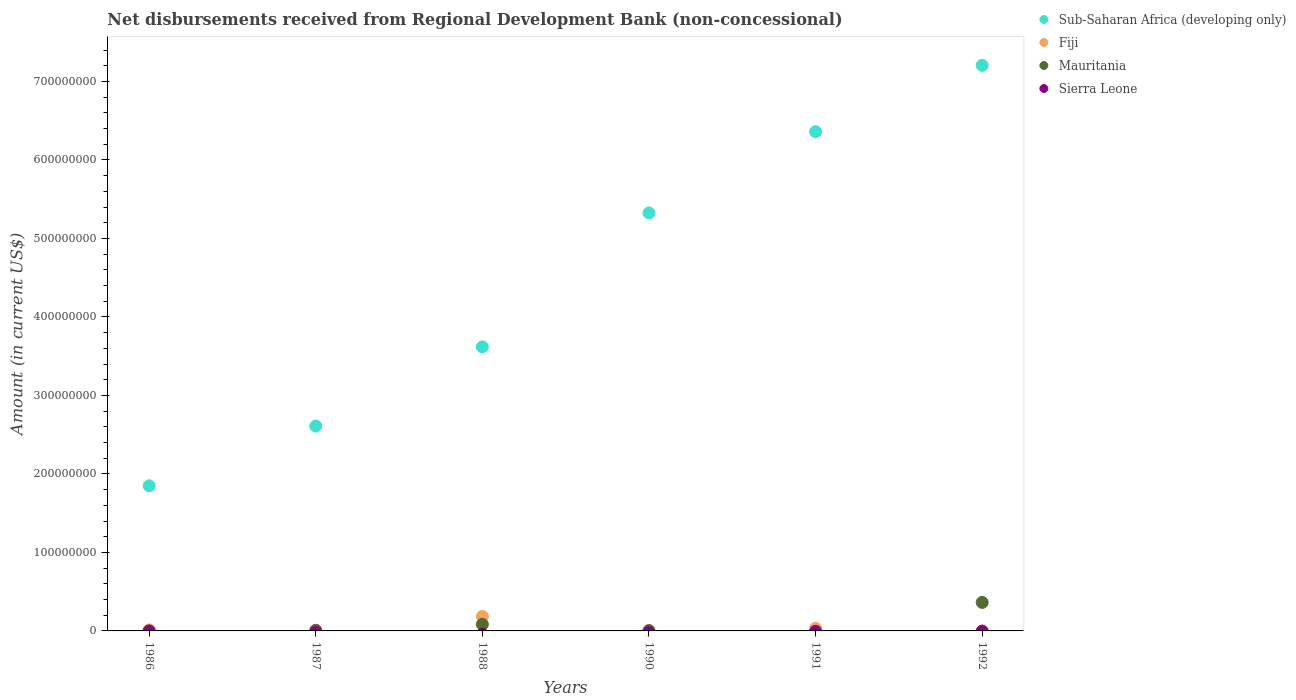Is the number of dotlines equal to the number of legend labels?
Ensure brevity in your answer.  No. What is the amount of disbursements received from Regional Development Bank in Mauritania in 1988?
Offer a very short reply. 8.38e+06. Across all years, what is the maximum amount of disbursements received from Regional Development Bank in Sub-Saharan Africa (developing only)?
Offer a very short reply. 7.20e+08. What is the total amount of disbursements received from Regional Development Bank in Sub-Saharan Africa (developing only) in the graph?
Offer a very short reply. 2.70e+09. What is the difference between the amount of disbursements received from Regional Development Bank in Mauritania in 1986 and that in 1990?
Provide a short and direct response. -5.11e+05. What is the difference between the amount of disbursements received from Regional Development Bank in Mauritania in 1992 and the amount of disbursements received from Regional Development Bank in Fiji in 1986?
Keep it short and to the point. 3.50e+07. What is the average amount of disbursements received from Regional Development Bank in Sierra Leone per year?
Make the answer very short. 0. In the year 1992, what is the difference between the amount of disbursements received from Regional Development Bank in Mauritania and amount of disbursements received from Regional Development Bank in Sub-Saharan Africa (developing only)?
Give a very brief answer. -6.84e+08. What is the ratio of the amount of disbursements received from Regional Development Bank in Fiji in 1987 to that in 1988?
Make the answer very short. 0.04. Is the amount of disbursements received from Regional Development Bank in Sub-Saharan Africa (developing only) in 1988 less than that in 1990?
Provide a short and direct response. Yes. Is the difference between the amount of disbursements received from Regional Development Bank in Mauritania in 1987 and 1990 greater than the difference between the amount of disbursements received from Regional Development Bank in Sub-Saharan Africa (developing only) in 1987 and 1990?
Offer a terse response. Yes. What is the difference between the highest and the second highest amount of disbursements received from Regional Development Bank in Fiji?
Offer a very short reply. 1.51e+07. What is the difference between the highest and the lowest amount of disbursements received from Regional Development Bank in Fiji?
Provide a short and direct response. 1.85e+07. In how many years, is the amount of disbursements received from Regional Development Bank in Fiji greater than the average amount of disbursements received from Regional Development Bank in Fiji taken over all years?
Your answer should be very brief. 1. Is the sum of the amount of disbursements received from Regional Development Bank in Mauritania in 1990 and 1992 greater than the maximum amount of disbursements received from Regional Development Bank in Fiji across all years?
Keep it short and to the point. Yes. Is the amount of disbursements received from Regional Development Bank in Sub-Saharan Africa (developing only) strictly greater than the amount of disbursements received from Regional Development Bank in Sierra Leone over the years?
Your answer should be compact. Yes. Is the amount of disbursements received from Regional Development Bank in Sierra Leone strictly less than the amount of disbursements received from Regional Development Bank in Fiji over the years?
Your answer should be compact. No. How many dotlines are there?
Your answer should be very brief. 3. How many years are there in the graph?
Offer a very short reply. 6. Does the graph contain any zero values?
Provide a short and direct response. Yes. How many legend labels are there?
Keep it short and to the point. 4. How are the legend labels stacked?
Your answer should be very brief. Vertical. What is the title of the graph?
Ensure brevity in your answer.  Net disbursements received from Regional Development Bank (non-concessional). Does "Kenya" appear as one of the legend labels in the graph?
Offer a very short reply. No. What is the label or title of the X-axis?
Provide a succinct answer. Years. What is the Amount (in current US$) of Sub-Saharan Africa (developing only) in 1986?
Keep it short and to the point. 1.85e+08. What is the Amount (in current US$) in Fiji in 1986?
Keep it short and to the point. 1.34e+06. What is the Amount (in current US$) of Mauritania in 1986?
Ensure brevity in your answer.  1.90e+04. What is the Amount (in current US$) of Sierra Leone in 1986?
Offer a very short reply. 0. What is the Amount (in current US$) of Sub-Saharan Africa (developing only) in 1987?
Your answer should be compact. 2.61e+08. What is the Amount (in current US$) in Fiji in 1987?
Your answer should be compact. 8.21e+05. What is the Amount (in current US$) of Mauritania in 1987?
Offer a terse response. 7.30e+05. What is the Amount (in current US$) in Sub-Saharan Africa (developing only) in 1988?
Make the answer very short. 3.62e+08. What is the Amount (in current US$) of Fiji in 1988?
Your response must be concise. 1.85e+07. What is the Amount (in current US$) of Mauritania in 1988?
Provide a short and direct response. 8.38e+06. What is the Amount (in current US$) in Sub-Saharan Africa (developing only) in 1990?
Your response must be concise. 5.33e+08. What is the Amount (in current US$) in Fiji in 1990?
Provide a succinct answer. 0. What is the Amount (in current US$) in Mauritania in 1990?
Provide a succinct answer. 5.30e+05. What is the Amount (in current US$) of Sub-Saharan Africa (developing only) in 1991?
Your answer should be very brief. 6.36e+08. What is the Amount (in current US$) of Fiji in 1991?
Make the answer very short. 3.35e+06. What is the Amount (in current US$) in Mauritania in 1991?
Make the answer very short. 0. What is the Amount (in current US$) in Sierra Leone in 1991?
Offer a very short reply. 0. What is the Amount (in current US$) of Sub-Saharan Africa (developing only) in 1992?
Your response must be concise. 7.20e+08. What is the Amount (in current US$) in Mauritania in 1992?
Provide a succinct answer. 3.63e+07. Across all years, what is the maximum Amount (in current US$) of Sub-Saharan Africa (developing only)?
Your answer should be compact. 7.20e+08. Across all years, what is the maximum Amount (in current US$) in Fiji?
Your answer should be compact. 1.85e+07. Across all years, what is the maximum Amount (in current US$) in Mauritania?
Your answer should be compact. 3.63e+07. Across all years, what is the minimum Amount (in current US$) in Sub-Saharan Africa (developing only)?
Your answer should be compact. 1.85e+08. Across all years, what is the minimum Amount (in current US$) in Fiji?
Give a very brief answer. 0. What is the total Amount (in current US$) in Sub-Saharan Africa (developing only) in the graph?
Ensure brevity in your answer.  2.70e+09. What is the total Amount (in current US$) of Fiji in the graph?
Ensure brevity in your answer.  2.40e+07. What is the total Amount (in current US$) in Mauritania in the graph?
Offer a terse response. 4.60e+07. What is the difference between the Amount (in current US$) of Sub-Saharan Africa (developing only) in 1986 and that in 1987?
Keep it short and to the point. -7.60e+07. What is the difference between the Amount (in current US$) in Fiji in 1986 and that in 1987?
Offer a terse response. 5.17e+05. What is the difference between the Amount (in current US$) of Mauritania in 1986 and that in 1987?
Offer a very short reply. -7.11e+05. What is the difference between the Amount (in current US$) of Sub-Saharan Africa (developing only) in 1986 and that in 1988?
Your answer should be very brief. -1.77e+08. What is the difference between the Amount (in current US$) of Fiji in 1986 and that in 1988?
Keep it short and to the point. -1.71e+07. What is the difference between the Amount (in current US$) of Mauritania in 1986 and that in 1988?
Your answer should be very brief. -8.36e+06. What is the difference between the Amount (in current US$) of Sub-Saharan Africa (developing only) in 1986 and that in 1990?
Make the answer very short. -3.48e+08. What is the difference between the Amount (in current US$) of Mauritania in 1986 and that in 1990?
Offer a very short reply. -5.11e+05. What is the difference between the Amount (in current US$) in Sub-Saharan Africa (developing only) in 1986 and that in 1991?
Ensure brevity in your answer.  -4.51e+08. What is the difference between the Amount (in current US$) of Fiji in 1986 and that in 1991?
Provide a succinct answer. -2.01e+06. What is the difference between the Amount (in current US$) of Sub-Saharan Africa (developing only) in 1986 and that in 1992?
Ensure brevity in your answer.  -5.36e+08. What is the difference between the Amount (in current US$) of Mauritania in 1986 and that in 1992?
Your answer should be very brief. -3.63e+07. What is the difference between the Amount (in current US$) of Sub-Saharan Africa (developing only) in 1987 and that in 1988?
Offer a very short reply. -1.01e+08. What is the difference between the Amount (in current US$) in Fiji in 1987 and that in 1988?
Offer a terse response. -1.76e+07. What is the difference between the Amount (in current US$) of Mauritania in 1987 and that in 1988?
Offer a very short reply. -7.65e+06. What is the difference between the Amount (in current US$) of Sub-Saharan Africa (developing only) in 1987 and that in 1990?
Provide a short and direct response. -2.72e+08. What is the difference between the Amount (in current US$) of Sub-Saharan Africa (developing only) in 1987 and that in 1991?
Keep it short and to the point. -3.75e+08. What is the difference between the Amount (in current US$) in Fiji in 1987 and that in 1991?
Make the answer very short. -2.53e+06. What is the difference between the Amount (in current US$) in Sub-Saharan Africa (developing only) in 1987 and that in 1992?
Keep it short and to the point. -4.60e+08. What is the difference between the Amount (in current US$) of Mauritania in 1987 and that in 1992?
Your answer should be very brief. -3.56e+07. What is the difference between the Amount (in current US$) of Sub-Saharan Africa (developing only) in 1988 and that in 1990?
Offer a terse response. -1.71e+08. What is the difference between the Amount (in current US$) in Mauritania in 1988 and that in 1990?
Offer a terse response. 7.85e+06. What is the difference between the Amount (in current US$) of Sub-Saharan Africa (developing only) in 1988 and that in 1991?
Ensure brevity in your answer.  -2.74e+08. What is the difference between the Amount (in current US$) of Fiji in 1988 and that in 1991?
Make the answer very short. 1.51e+07. What is the difference between the Amount (in current US$) of Sub-Saharan Africa (developing only) in 1988 and that in 1992?
Give a very brief answer. -3.59e+08. What is the difference between the Amount (in current US$) of Mauritania in 1988 and that in 1992?
Make the answer very short. -2.79e+07. What is the difference between the Amount (in current US$) in Sub-Saharan Africa (developing only) in 1990 and that in 1991?
Offer a very short reply. -1.03e+08. What is the difference between the Amount (in current US$) of Sub-Saharan Africa (developing only) in 1990 and that in 1992?
Offer a very short reply. -1.88e+08. What is the difference between the Amount (in current US$) of Mauritania in 1990 and that in 1992?
Your answer should be compact. -3.58e+07. What is the difference between the Amount (in current US$) of Sub-Saharan Africa (developing only) in 1991 and that in 1992?
Provide a succinct answer. -8.45e+07. What is the difference between the Amount (in current US$) of Sub-Saharan Africa (developing only) in 1986 and the Amount (in current US$) of Fiji in 1987?
Your answer should be compact. 1.84e+08. What is the difference between the Amount (in current US$) of Sub-Saharan Africa (developing only) in 1986 and the Amount (in current US$) of Mauritania in 1987?
Make the answer very short. 1.84e+08. What is the difference between the Amount (in current US$) in Fiji in 1986 and the Amount (in current US$) in Mauritania in 1987?
Give a very brief answer. 6.08e+05. What is the difference between the Amount (in current US$) of Sub-Saharan Africa (developing only) in 1986 and the Amount (in current US$) of Fiji in 1988?
Your response must be concise. 1.66e+08. What is the difference between the Amount (in current US$) of Sub-Saharan Africa (developing only) in 1986 and the Amount (in current US$) of Mauritania in 1988?
Give a very brief answer. 1.77e+08. What is the difference between the Amount (in current US$) of Fiji in 1986 and the Amount (in current US$) of Mauritania in 1988?
Offer a very short reply. -7.04e+06. What is the difference between the Amount (in current US$) of Sub-Saharan Africa (developing only) in 1986 and the Amount (in current US$) of Mauritania in 1990?
Provide a succinct answer. 1.84e+08. What is the difference between the Amount (in current US$) in Fiji in 1986 and the Amount (in current US$) in Mauritania in 1990?
Give a very brief answer. 8.08e+05. What is the difference between the Amount (in current US$) in Sub-Saharan Africa (developing only) in 1986 and the Amount (in current US$) in Fiji in 1991?
Ensure brevity in your answer.  1.82e+08. What is the difference between the Amount (in current US$) of Sub-Saharan Africa (developing only) in 1986 and the Amount (in current US$) of Mauritania in 1992?
Provide a short and direct response. 1.49e+08. What is the difference between the Amount (in current US$) of Fiji in 1986 and the Amount (in current US$) of Mauritania in 1992?
Give a very brief answer. -3.50e+07. What is the difference between the Amount (in current US$) of Sub-Saharan Africa (developing only) in 1987 and the Amount (in current US$) of Fiji in 1988?
Your answer should be very brief. 2.42e+08. What is the difference between the Amount (in current US$) in Sub-Saharan Africa (developing only) in 1987 and the Amount (in current US$) in Mauritania in 1988?
Provide a short and direct response. 2.53e+08. What is the difference between the Amount (in current US$) in Fiji in 1987 and the Amount (in current US$) in Mauritania in 1988?
Offer a terse response. -7.56e+06. What is the difference between the Amount (in current US$) of Sub-Saharan Africa (developing only) in 1987 and the Amount (in current US$) of Mauritania in 1990?
Provide a short and direct response. 2.60e+08. What is the difference between the Amount (in current US$) in Fiji in 1987 and the Amount (in current US$) in Mauritania in 1990?
Offer a very short reply. 2.91e+05. What is the difference between the Amount (in current US$) of Sub-Saharan Africa (developing only) in 1987 and the Amount (in current US$) of Fiji in 1991?
Your response must be concise. 2.58e+08. What is the difference between the Amount (in current US$) in Sub-Saharan Africa (developing only) in 1987 and the Amount (in current US$) in Mauritania in 1992?
Your answer should be compact. 2.25e+08. What is the difference between the Amount (in current US$) of Fiji in 1987 and the Amount (in current US$) of Mauritania in 1992?
Your answer should be compact. -3.55e+07. What is the difference between the Amount (in current US$) in Sub-Saharan Africa (developing only) in 1988 and the Amount (in current US$) in Mauritania in 1990?
Offer a very short reply. 3.61e+08. What is the difference between the Amount (in current US$) in Fiji in 1988 and the Amount (in current US$) in Mauritania in 1990?
Offer a very short reply. 1.79e+07. What is the difference between the Amount (in current US$) of Sub-Saharan Africa (developing only) in 1988 and the Amount (in current US$) of Fiji in 1991?
Provide a succinct answer. 3.58e+08. What is the difference between the Amount (in current US$) in Sub-Saharan Africa (developing only) in 1988 and the Amount (in current US$) in Mauritania in 1992?
Offer a very short reply. 3.26e+08. What is the difference between the Amount (in current US$) of Fiji in 1988 and the Amount (in current US$) of Mauritania in 1992?
Provide a succinct answer. -1.79e+07. What is the difference between the Amount (in current US$) of Sub-Saharan Africa (developing only) in 1990 and the Amount (in current US$) of Fiji in 1991?
Ensure brevity in your answer.  5.29e+08. What is the difference between the Amount (in current US$) in Sub-Saharan Africa (developing only) in 1990 and the Amount (in current US$) in Mauritania in 1992?
Your answer should be very brief. 4.96e+08. What is the difference between the Amount (in current US$) of Sub-Saharan Africa (developing only) in 1991 and the Amount (in current US$) of Mauritania in 1992?
Ensure brevity in your answer.  6.00e+08. What is the difference between the Amount (in current US$) of Fiji in 1991 and the Amount (in current US$) of Mauritania in 1992?
Your response must be concise. -3.30e+07. What is the average Amount (in current US$) of Sub-Saharan Africa (developing only) per year?
Give a very brief answer. 4.49e+08. What is the average Amount (in current US$) of Fiji per year?
Your answer should be very brief. 3.99e+06. What is the average Amount (in current US$) of Mauritania per year?
Your answer should be compact. 7.66e+06. In the year 1986, what is the difference between the Amount (in current US$) of Sub-Saharan Africa (developing only) and Amount (in current US$) of Fiji?
Keep it short and to the point. 1.84e+08. In the year 1986, what is the difference between the Amount (in current US$) of Sub-Saharan Africa (developing only) and Amount (in current US$) of Mauritania?
Give a very brief answer. 1.85e+08. In the year 1986, what is the difference between the Amount (in current US$) in Fiji and Amount (in current US$) in Mauritania?
Give a very brief answer. 1.32e+06. In the year 1987, what is the difference between the Amount (in current US$) of Sub-Saharan Africa (developing only) and Amount (in current US$) of Fiji?
Your response must be concise. 2.60e+08. In the year 1987, what is the difference between the Amount (in current US$) in Sub-Saharan Africa (developing only) and Amount (in current US$) in Mauritania?
Your answer should be compact. 2.60e+08. In the year 1987, what is the difference between the Amount (in current US$) of Fiji and Amount (in current US$) of Mauritania?
Offer a very short reply. 9.10e+04. In the year 1988, what is the difference between the Amount (in current US$) in Sub-Saharan Africa (developing only) and Amount (in current US$) in Fiji?
Make the answer very short. 3.43e+08. In the year 1988, what is the difference between the Amount (in current US$) in Sub-Saharan Africa (developing only) and Amount (in current US$) in Mauritania?
Your answer should be compact. 3.53e+08. In the year 1988, what is the difference between the Amount (in current US$) in Fiji and Amount (in current US$) in Mauritania?
Your answer should be compact. 1.01e+07. In the year 1990, what is the difference between the Amount (in current US$) of Sub-Saharan Africa (developing only) and Amount (in current US$) of Mauritania?
Your response must be concise. 5.32e+08. In the year 1991, what is the difference between the Amount (in current US$) in Sub-Saharan Africa (developing only) and Amount (in current US$) in Fiji?
Make the answer very short. 6.33e+08. In the year 1992, what is the difference between the Amount (in current US$) in Sub-Saharan Africa (developing only) and Amount (in current US$) in Mauritania?
Offer a terse response. 6.84e+08. What is the ratio of the Amount (in current US$) in Sub-Saharan Africa (developing only) in 1986 to that in 1987?
Your answer should be compact. 0.71. What is the ratio of the Amount (in current US$) in Fiji in 1986 to that in 1987?
Your answer should be very brief. 1.63. What is the ratio of the Amount (in current US$) of Mauritania in 1986 to that in 1987?
Make the answer very short. 0.03. What is the ratio of the Amount (in current US$) of Sub-Saharan Africa (developing only) in 1986 to that in 1988?
Keep it short and to the point. 0.51. What is the ratio of the Amount (in current US$) of Fiji in 1986 to that in 1988?
Give a very brief answer. 0.07. What is the ratio of the Amount (in current US$) in Mauritania in 1986 to that in 1988?
Keep it short and to the point. 0. What is the ratio of the Amount (in current US$) of Sub-Saharan Africa (developing only) in 1986 to that in 1990?
Your answer should be compact. 0.35. What is the ratio of the Amount (in current US$) of Mauritania in 1986 to that in 1990?
Offer a very short reply. 0.04. What is the ratio of the Amount (in current US$) of Sub-Saharan Africa (developing only) in 1986 to that in 1991?
Provide a short and direct response. 0.29. What is the ratio of the Amount (in current US$) in Fiji in 1986 to that in 1991?
Give a very brief answer. 0.4. What is the ratio of the Amount (in current US$) in Sub-Saharan Africa (developing only) in 1986 to that in 1992?
Offer a terse response. 0.26. What is the ratio of the Amount (in current US$) in Mauritania in 1986 to that in 1992?
Your response must be concise. 0. What is the ratio of the Amount (in current US$) of Sub-Saharan Africa (developing only) in 1987 to that in 1988?
Keep it short and to the point. 0.72. What is the ratio of the Amount (in current US$) in Fiji in 1987 to that in 1988?
Keep it short and to the point. 0.04. What is the ratio of the Amount (in current US$) of Mauritania in 1987 to that in 1988?
Your answer should be compact. 0.09. What is the ratio of the Amount (in current US$) in Sub-Saharan Africa (developing only) in 1987 to that in 1990?
Offer a terse response. 0.49. What is the ratio of the Amount (in current US$) in Mauritania in 1987 to that in 1990?
Keep it short and to the point. 1.38. What is the ratio of the Amount (in current US$) of Sub-Saharan Africa (developing only) in 1987 to that in 1991?
Your answer should be compact. 0.41. What is the ratio of the Amount (in current US$) of Fiji in 1987 to that in 1991?
Ensure brevity in your answer.  0.24. What is the ratio of the Amount (in current US$) in Sub-Saharan Africa (developing only) in 1987 to that in 1992?
Provide a succinct answer. 0.36. What is the ratio of the Amount (in current US$) of Mauritania in 1987 to that in 1992?
Keep it short and to the point. 0.02. What is the ratio of the Amount (in current US$) in Sub-Saharan Africa (developing only) in 1988 to that in 1990?
Keep it short and to the point. 0.68. What is the ratio of the Amount (in current US$) of Mauritania in 1988 to that in 1990?
Your response must be concise. 15.81. What is the ratio of the Amount (in current US$) in Sub-Saharan Africa (developing only) in 1988 to that in 1991?
Your response must be concise. 0.57. What is the ratio of the Amount (in current US$) of Fiji in 1988 to that in 1991?
Make the answer very short. 5.51. What is the ratio of the Amount (in current US$) of Sub-Saharan Africa (developing only) in 1988 to that in 1992?
Keep it short and to the point. 0.5. What is the ratio of the Amount (in current US$) of Mauritania in 1988 to that in 1992?
Give a very brief answer. 0.23. What is the ratio of the Amount (in current US$) of Sub-Saharan Africa (developing only) in 1990 to that in 1991?
Ensure brevity in your answer.  0.84. What is the ratio of the Amount (in current US$) in Sub-Saharan Africa (developing only) in 1990 to that in 1992?
Keep it short and to the point. 0.74. What is the ratio of the Amount (in current US$) of Mauritania in 1990 to that in 1992?
Provide a short and direct response. 0.01. What is the ratio of the Amount (in current US$) of Sub-Saharan Africa (developing only) in 1991 to that in 1992?
Offer a terse response. 0.88. What is the difference between the highest and the second highest Amount (in current US$) in Sub-Saharan Africa (developing only)?
Offer a terse response. 8.45e+07. What is the difference between the highest and the second highest Amount (in current US$) of Fiji?
Keep it short and to the point. 1.51e+07. What is the difference between the highest and the second highest Amount (in current US$) of Mauritania?
Your response must be concise. 2.79e+07. What is the difference between the highest and the lowest Amount (in current US$) in Sub-Saharan Africa (developing only)?
Offer a very short reply. 5.36e+08. What is the difference between the highest and the lowest Amount (in current US$) of Fiji?
Provide a short and direct response. 1.85e+07. What is the difference between the highest and the lowest Amount (in current US$) in Mauritania?
Make the answer very short. 3.63e+07. 